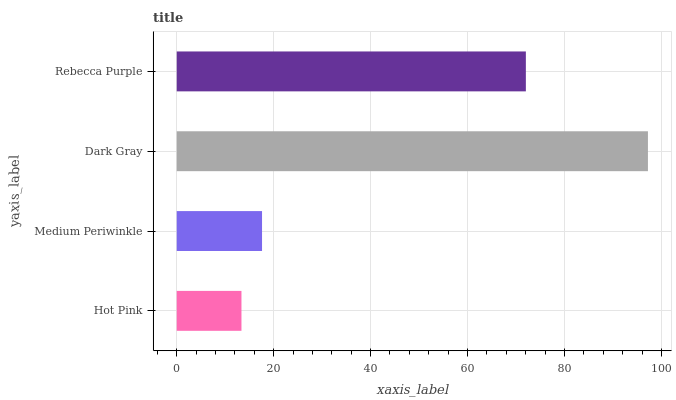Is Hot Pink the minimum?
Answer yes or no. Yes. Is Dark Gray the maximum?
Answer yes or no. Yes. Is Medium Periwinkle the minimum?
Answer yes or no. No. Is Medium Periwinkle the maximum?
Answer yes or no. No. Is Medium Periwinkle greater than Hot Pink?
Answer yes or no. Yes. Is Hot Pink less than Medium Periwinkle?
Answer yes or no. Yes. Is Hot Pink greater than Medium Periwinkle?
Answer yes or no. No. Is Medium Periwinkle less than Hot Pink?
Answer yes or no. No. Is Rebecca Purple the high median?
Answer yes or no. Yes. Is Medium Periwinkle the low median?
Answer yes or no. Yes. Is Dark Gray the high median?
Answer yes or no. No. Is Rebecca Purple the low median?
Answer yes or no. No. 